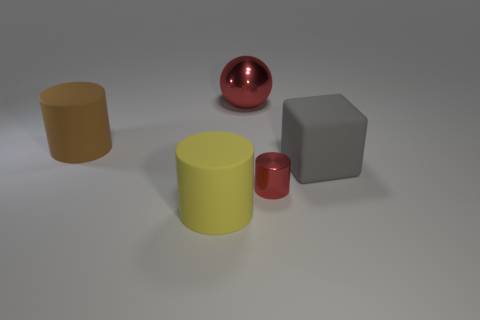Subtract all large cylinders. How many cylinders are left? 1 Subtract all cylinders. How many objects are left? 2 Subtract 1 cylinders. How many cylinders are left? 2 Subtract all brown cylinders. Subtract all cyan balls. How many cylinders are left? 2 Subtract all blue spheres. How many brown blocks are left? 0 Subtract all small red cubes. Subtract all yellow things. How many objects are left? 4 Add 1 big red spheres. How many big red spheres are left? 2 Add 1 blue rubber blocks. How many blue rubber blocks exist? 1 Add 3 big yellow cylinders. How many objects exist? 8 Subtract all yellow cylinders. How many cylinders are left? 2 